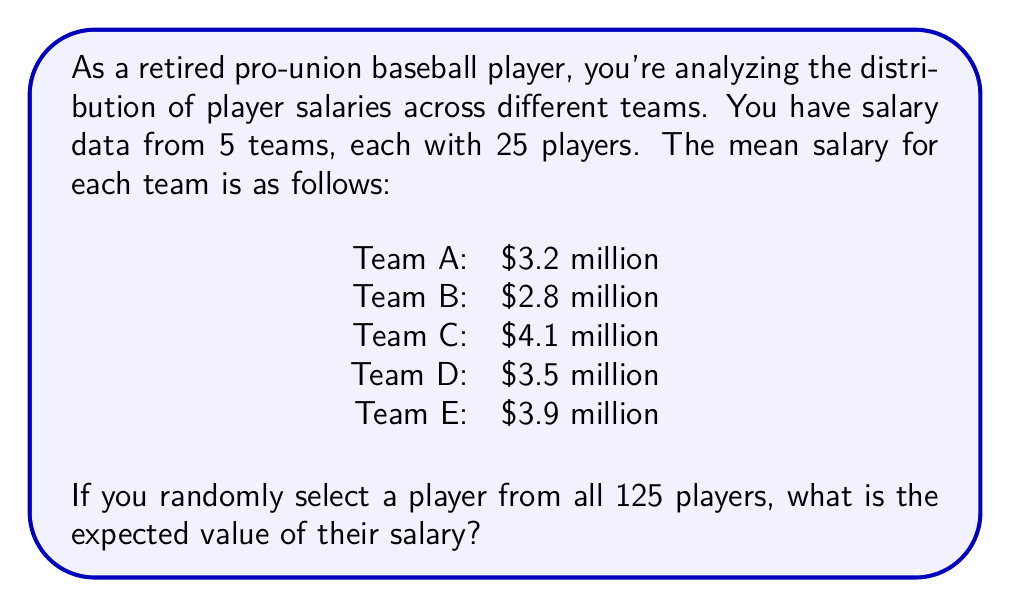Can you solve this math problem? Let's approach this step-by-step:

1) First, we need to understand what the question is asking. We're looking for the expected value of a randomly selected player's salary from all teams combined.

2) In this case, the expected value is equivalent to the overall mean salary across all teams.

3) To calculate this, we need to find the total sum of all salaries and divide it by the total number of players.

4) We can calculate the total sum of salaries for each team:

   Team A: $3.2 million × 25 = $80 million
   Team B: $2.8 million × 25 = $70 million
   Team C: $4.1 million × 25 = $102.5 million
   Team D: $3.5 million × 25 = $87.5 million
   Team E: $3.9 million × 25 = $97.5 million

5) Now, let's sum up all team totals:

   $80 + $70 + $102.5 + $87.5 + $97.5 = $437.5 million

6) The total number of players is 5 × 25 = 125

7) The expected value (overall mean) is:

   $$E(X) = \frac{\text{Total sum of salaries}}{\text{Total number of players}} = \frac{437.5}{125} = 3.5$$

Therefore, the expected value of a randomly selected player's salary is $3.5 million.
Answer: $3.5 million 